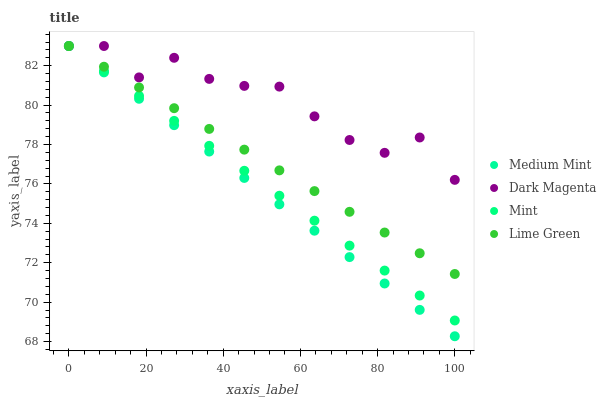Does Medium Mint have the minimum area under the curve?
Answer yes or no. Yes. Does Dark Magenta have the maximum area under the curve?
Answer yes or no. Yes. Does Lime Green have the minimum area under the curve?
Answer yes or no. No. Does Lime Green have the maximum area under the curve?
Answer yes or no. No. Is Mint the smoothest?
Answer yes or no. Yes. Is Dark Magenta the roughest?
Answer yes or no. Yes. Is Lime Green the smoothest?
Answer yes or no. No. Is Lime Green the roughest?
Answer yes or no. No. Does Medium Mint have the lowest value?
Answer yes or no. Yes. Does Lime Green have the lowest value?
Answer yes or no. No. Does Dark Magenta have the highest value?
Answer yes or no. Yes. Does Mint intersect Medium Mint?
Answer yes or no. Yes. Is Mint less than Medium Mint?
Answer yes or no. No. Is Mint greater than Medium Mint?
Answer yes or no. No. 